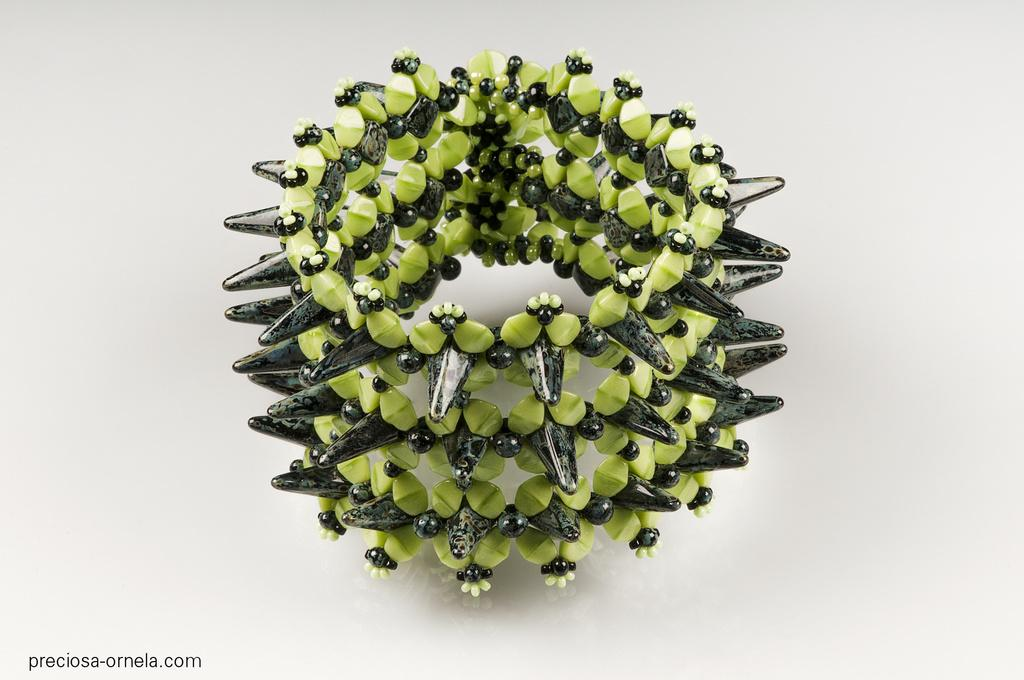What is the main subject of the image? The main subject of the image is an object made up of colorful beads. Can you describe any additional features of the image? Yes, there is a watermark on the image. How many rabbits are present in the image? There are no rabbits present in the image. What type of hat is the lawyer wearing in the image? There is no lawyer or hat present in the image. 